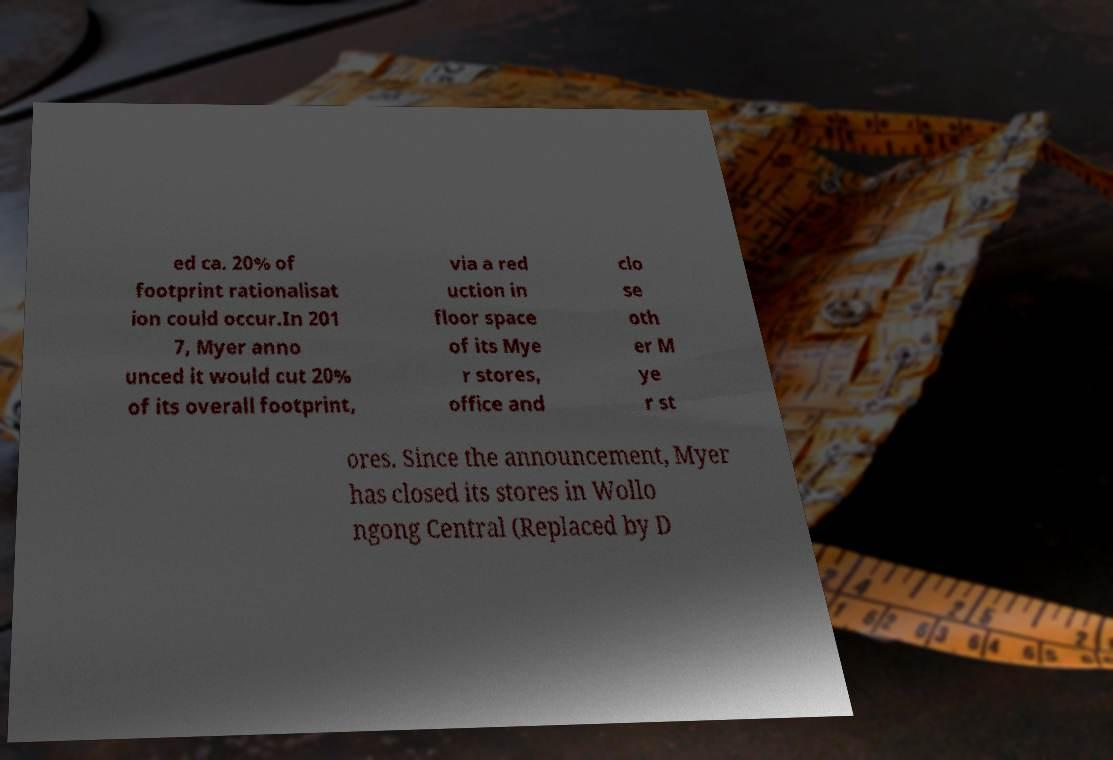I need the written content from this picture converted into text. Can you do that? ed ca. 20% of footprint rationalisat ion could occur.In 201 7, Myer anno unced it would cut 20% of its overall footprint, via a red uction in floor space of its Mye r stores, office and clo se oth er M ye r st ores. Since the announcement, Myer has closed its stores in Wollo ngong Central (Replaced by D 